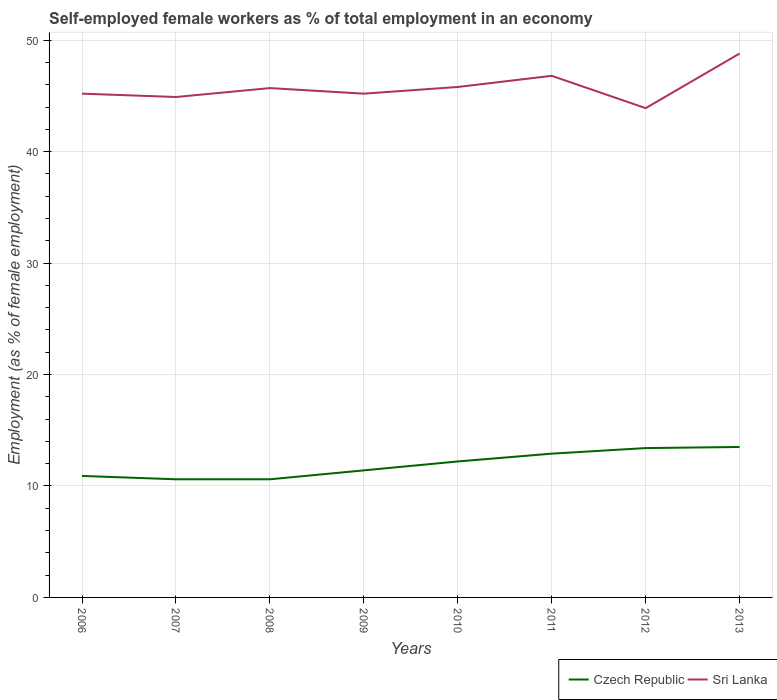How many different coloured lines are there?
Provide a short and direct response. 2. Is the number of lines equal to the number of legend labels?
Provide a short and direct response. Yes. Across all years, what is the maximum percentage of self-employed female workers in Czech Republic?
Provide a short and direct response. 10.6. In which year was the percentage of self-employed female workers in Sri Lanka maximum?
Offer a terse response. 2012. What is the total percentage of self-employed female workers in Sri Lanka in the graph?
Give a very brief answer. -0.6. What is the difference between the highest and the second highest percentage of self-employed female workers in Sri Lanka?
Offer a terse response. 4.9. How many lines are there?
Provide a short and direct response. 2. Are the values on the major ticks of Y-axis written in scientific E-notation?
Ensure brevity in your answer.  No. Does the graph contain grids?
Provide a succinct answer. Yes. Where does the legend appear in the graph?
Give a very brief answer. Bottom right. How many legend labels are there?
Offer a very short reply. 2. What is the title of the graph?
Your answer should be compact. Self-employed female workers as % of total employment in an economy. What is the label or title of the Y-axis?
Give a very brief answer. Employment (as % of female employment). What is the Employment (as % of female employment) of Czech Republic in 2006?
Give a very brief answer. 10.9. What is the Employment (as % of female employment) of Sri Lanka in 2006?
Ensure brevity in your answer.  45.2. What is the Employment (as % of female employment) in Czech Republic in 2007?
Make the answer very short. 10.6. What is the Employment (as % of female employment) in Sri Lanka in 2007?
Offer a very short reply. 44.9. What is the Employment (as % of female employment) in Czech Republic in 2008?
Keep it short and to the point. 10.6. What is the Employment (as % of female employment) of Sri Lanka in 2008?
Provide a short and direct response. 45.7. What is the Employment (as % of female employment) in Czech Republic in 2009?
Give a very brief answer. 11.4. What is the Employment (as % of female employment) in Sri Lanka in 2009?
Your response must be concise. 45.2. What is the Employment (as % of female employment) in Czech Republic in 2010?
Make the answer very short. 12.2. What is the Employment (as % of female employment) of Sri Lanka in 2010?
Provide a short and direct response. 45.8. What is the Employment (as % of female employment) of Czech Republic in 2011?
Offer a terse response. 12.9. What is the Employment (as % of female employment) in Sri Lanka in 2011?
Keep it short and to the point. 46.8. What is the Employment (as % of female employment) of Czech Republic in 2012?
Your response must be concise. 13.4. What is the Employment (as % of female employment) of Sri Lanka in 2012?
Provide a succinct answer. 43.9. What is the Employment (as % of female employment) of Sri Lanka in 2013?
Provide a short and direct response. 48.8. Across all years, what is the maximum Employment (as % of female employment) of Czech Republic?
Provide a succinct answer. 13.5. Across all years, what is the maximum Employment (as % of female employment) of Sri Lanka?
Provide a short and direct response. 48.8. Across all years, what is the minimum Employment (as % of female employment) of Czech Republic?
Give a very brief answer. 10.6. Across all years, what is the minimum Employment (as % of female employment) of Sri Lanka?
Provide a short and direct response. 43.9. What is the total Employment (as % of female employment) of Czech Republic in the graph?
Keep it short and to the point. 95.5. What is the total Employment (as % of female employment) in Sri Lanka in the graph?
Keep it short and to the point. 366.3. What is the difference between the Employment (as % of female employment) of Czech Republic in 2006 and that in 2007?
Provide a succinct answer. 0.3. What is the difference between the Employment (as % of female employment) in Czech Republic in 2006 and that in 2008?
Offer a terse response. 0.3. What is the difference between the Employment (as % of female employment) in Sri Lanka in 2006 and that in 2008?
Your answer should be compact. -0.5. What is the difference between the Employment (as % of female employment) of Czech Republic in 2006 and that in 2009?
Your answer should be very brief. -0.5. What is the difference between the Employment (as % of female employment) of Czech Republic in 2006 and that in 2011?
Keep it short and to the point. -2. What is the difference between the Employment (as % of female employment) of Czech Republic in 2006 and that in 2012?
Give a very brief answer. -2.5. What is the difference between the Employment (as % of female employment) in Sri Lanka in 2006 and that in 2012?
Your answer should be compact. 1.3. What is the difference between the Employment (as % of female employment) in Czech Republic in 2007 and that in 2008?
Provide a succinct answer. 0. What is the difference between the Employment (as % of female employment) in Sri Lanka in 2007 and that in 2008?
Give a very brief answer. -0.8. What is the difference between the Employment (as % of female employment) of Czech Republic in 2007 and that in 2009?
Offer a terse response. -0.8. What is the difference between the Employment (as % of female employment) in Czech Republic in 2007 and that in 2010?
Make the answer very short. -1.6. What is the difference between the Employment (as % of female employment) of Czech Republic in 2007 and that in 2011?
Provide a short and direct response. -2.3. What is the difference between the Employment (as % of female employment) of Sri Lanka in 2007 and that in 2012?
Ensure brevity in your answer.  1. What is the difference between the Employment (as % of female employment) in Czech Republic in 2008 and that in 2011?
Your answer should be compact. -2.3. What is the difference between the Employment (as % of female employment) in Sri Lanka in 2008 and that in 2011?
Make the answer very short. -1.1. What is the difference between the Employment (as % of female employment) of Czech Republic in 2008 and that in 2012?
Keep it short and to the point. -2.8. What is the difference between the Employment (as % of female employment) in Czech Republic in 2008 and that in 2013?
Offer a terse response. -2.9. What is the difference between the Employment (as % of female employment) in Sri Lanka in 2008 and that in 2013?
Give a very brief answer. -3.1. What is the difference between the Employment (as % of female employment) of Czech Republic in 2009 and that in 2010?
Keep it short and to the point. -0.8. What is the difference between the Employment (as % of female employment) of Sri Lanka in 2009 and that in 2010?
Your response must be concise. -0.6. What is the difference between the Employment (as % of female employment) in Sri Lanka in 2009 and that in 2011?
Ensure brevity in your answer.  -1.6. What is the difference between the Employment (as % of female employment) of Czech Republic in 2009 and that in 2012?
Provide a succinct answer. -2. What is the difference between the Employment (as % of female employment) of Sri Lanka in 2009 and that in 2013?
Make the answer very short. -3.6. What is the difference between the Employment (as % of female employment) of Czech Republic in 2010 and that in 2011?
Ensure brevity in your answer.  -0.7. What is the difference between the Employment (as % of female employment) in Czech Republic in 2010 and that in 2013?
Ensure brevity in your answer.  -1.3. What is the difference between the Employment (as % of female employment) in Czech Republic in 2011 and that in 2012?
Provide a short and direct response. -0.5. What is the difference between the Employment (as % of female employment) of Sri Lanka in 2011 and that in 2012?
Your answer should be very brief. 2.9. What is the difference between the Employment (as % of female employment) in Sri Lanka in 2011 and that in 2013?
Ensure brevity in your answer.  -2. What is the difference between the Employment (as % of female employment) in Czech Republic in 2012 and that in 2013?
Ensure brevity in your answer.  -0.1. What is the difference between the Employment (as % of female employment) in Czech Republic in 2006 and the Employment (as % of female employment) in Sri Lanka in 2007?
Give a very brief answer. -34. What is the difference between the Employment (as % of female employment) in Czech Republic in 2006 and the Employment (as % of female employment) in Sri Lanka in 2008?
Offer a very short reply. -34.8. What is the difference between the Employment (as % of female employment) of Czech Republic in 2006 and the Employment (as % of female employment) of Sri Lanka in 2009?
Ensure brevity in your answer.  -34.3. What is the difference between the Employment (as % of female employment) in Czech Republic in 2006 and the Employment (as % of female employment) in Sri Lanka in 2010?
Give a very brief answer. -34.9. What is the difference between the Employment (as % of female employment) in Czech Republic in 2006 and the Employment (as % of female employment) in Sri Lanka in 2011?
Provide a short and direct response. -35.9. What is the difference between the Employment (as % of female employment) in Czech Republic in 2006 and the Employment (as % of female employment) in Sri Lanka in 2012?
Ensure brevity in your answer.  -33. What is the difference between the Employment (as % of female employment) in Czech Republic in 2006 and the Employment (as % of female employment) in Sri Lanka in 2013?
Provide a succinct answer. -37.9. What is the difference between the Employment (as % of female employment) in Czech Republic in 2007 and the Employment (as % of female employment) in Sri Lanka in 2008?
Offer a very short reply. -35.1. What is the difference between the Employment (as % of female employment) in Czech Republic in 2007 and the Employment (as % of female employment) in Sri Lanka in 2009?
Offer a terse response. -34.6. What is the difference between the Employment (as % of female employment) of Czech Republic in 2007 and the Employment (as % of female employment) of Sri Lanka in 2010?
Make the answer very short. -35.2. What is the difference between the Employment (as % of female employment) of Czech Republic in 2007 and the Employment (as % of female employment) of Sri Lanka in 2011?
Your answer should be compact. -36.2. What is the difference between the Employment (as % of female employment) of Czech Republic in 2007 and the Employment (as % of female employment) of Sri Lanka in 2012?
Give a very brief answer. -33.3. What is the difference between the Employment (as % of female employment) of Czech Republic in 2007 and the Employment (as % of female employment) of Sri Lanka in 2013?
Your answer should be very brief. -38.2. What is the difference between the Employment (as % of female employment) in Czech Republic in 2008 and the Employment (as % of female employment) in Sri Lanka in 2009?
Provide a short and direct response. -34.6. What is the difference between the Employment (as % of female employment) of Czech Republic in 2008 and the Employment (as % of female employment) of Sri Lanka in 2010?
Offer a terse response. -35.2. What is the difference between the Employment (as % of female employment) of Czech Republic in 2008 and the Employment (as % of female employment) of Sri Lanka in 2011?
Ensure brevity in your answer.  -36.2. What is the difference between the Employment (as % of female employment) in Czech Republic in 2008 and the Employment (as % of female employment) in Sri Lanka in 2012?
Offer a very short reply. -33.3. What is the difference between the Employment (as % of female employment) in Czech Republic in 2008 and the Employment (as % of female employment) in Sri Lanka in 2013?
Your answer should be compact. -38.2. What is the difference between the Employment (as % of female employment) in Czech Republic in 2009 and the Employment (as % of female employment) in Sri Lanka in 2010?
Offer a very short reply. -34.4. What is the difference between the Employment (as % of female employment) of Czech Republic in 2009 and the Employment (as % of female employment) of Sri Lanka in 2011?
Offer a very short reply. -35.4. What is the difference between the Employment (as % of female employment) of Czech Republic in 2009 and the Employment (as % of female employment) of Sri Lanka in 2012?
Provide a succinct answer. -32.5. What is the difference between the Employment (as % of female employment) of Czech Republic in 2009 and the Employment (as % of female employment) of Sri Lanka in 2013?
Provide a succinct answer. -37.4. What is the difference between the Employment (as % of female employment) in Czech Republic in 2010 and the Employment (as % of female employment) in Sri Lanka in 2011?
Provide a succinct answer. -34.6. What is the difference between the Employment (as % of female employment) of Czech Republic in 2010 and the Employment (as % of female employment) of Sri Lanka in 2012?
Your answer should be very brief. -31.7. What is the difference between the Employment (as % of female employment) in Czech Republic in 2010 and the Employment (as % of female employment) in Sri Lanka in 2013?
Keep it short and to the point. -36.6. What is the difference between the Employment (as % of female employment) of Czech Republic in 2011 and the Employment (as % of female employment) of Sri Lanka in 2012?
Ensure brevity in your answer.  -31. What is the difference between the Employment (as % of female employment) in Czech Republic in 2011 and the Employment (as % of female employment) in Sri Lanka in 2013?
Give a very brief answer. -35.9. What is the difference between the Employment (as % of female employment) in Czech Republic in 2012 and the Employment (as % of female employment) in Sri Lanka in 2013?
Provide a succinct answer. -35.4. What is the average Employment (as % of female employment) in Czech Republic per year?
Your answer should be compact. 11.94. What is the average Employment (as % of female employment) in Sri Lanka per year?
Your response must be concise. 45.79. In the year 2006, what is the difference between the Employment (as % of female employment) of Czech Republic and Employment (as % of female employment) of Sri Lanka?
Your answer should be compact. -34.3. In the year 2007, what is the difference between the Employment (as % of female employment) in Czech Republic and Employment (as % of female employment) in Sri Lanka?
Your answer should be very brief. -34.3. In the year 2008, what is the difference between the Employment (as % of female employment) in Czech Republic and Employment (as % of female employment) in Sri Lanka?
Offer a very short reply. -35.1. In the year 2009, what is the difference between the Employment (as % of female employment) in Czech Republic and Employment (as % of female employment) in Sri Lanka?
Your answer should be very brief. -33.8. In the year 2010, what is the difference between the Employment (as % of female employment) of Czech Republic and Employment (as % of female employment) of Sri Lanka?
Your response must be concise. -33.6. In the year 2011, what is the difference between the Employment (as % of female employment) in Czech Republic and Employment (as % of female employment) in Sri Lanka?
Ensure brevity in your answer.  -33.9. In the year 2012, what is the difference between the Employment (as % of female employment) in Czech Republic and Employment (as % of female employment) in Sri Lanka?
Offer a very short reply. -30.5. In the year 2013, what is the difference between the Employment (as % of female employment) in Czech Republic and Employment (as % of female employment) in Sri Lanka?
Offer a terse response. -35.3. What is the ratio of the Employment (as % of female employment) of Czech Republic in 2006 to that in 2007?
Your response must be concise. 1.03. What is the ratio of the Employment (as % of female employment) of Sri Lanka in 2006 to that in 2007?
Provide a short and direct response. 1.01. What is the ratio of the Employment (as % of female employment) in Czech Republic in 2006 to that in 2008?
Ensure brevity in your answer.  1.03. What is the ratio of the Employment (as % of female employment) in Sri Lanka in 2006 to that in 2008?
Make the answer very short. 0.99. What is the ratio of the Employment (as % of female employment) of Czech Republic in 2006 to that in 2009?
Offer a very short reply. 0.96. What is the ratio of the Employment (as % of female employment) in Czech Republic in 2006 to that in 2010?
Provide a succinct answer. 0.89. What is the ratio of the Employment (as % of female employment) of Sri Lanka in 2006 to that in 2010?
Ensure brevity in your answer.  0.99. What is the ratio of the Employment (as % of female employment) of Czech Republic in 2006 to that in 2011?
Provide a succinct answer. 0.84. What is the ratio of the Employment (as % of female employment) of Sri Lanka in 2006 to that in 2011?
Your answer should be compact. 0.97. What is the ratio of the Employment (as % of female employment) of Czech Republic in 2006 to that in 2012?
Provide a succinct answer. 0.81. What is the ratio of the Employment (as % of female employment) in Sri Lanka in 2006 to that in 2012?
Your answer should be very brief. 1.03. What is the ratio of the Employment (as % of female employment) in Czech Republic in 2006 to that in 2013?
Offer a terse response. 0.81. What is the ratio of the Employment (as % of female employment) of Sri Lanka in 2006 to that in 2013?
Keep it short and to the point. 0.93. What is the ratio of the Employment (as % of female employment) of Czech Republic in 2007 to that in 2008?
Your answer should be compact. 1. What is the ratio of the Employment (as % of female employment) in Sri Lanka in 2007 to that in 2008?
Your answer should be very brief. 0.98. What is the ratio of the Employment (as % of female employment) in Czech Republic in 2007 to that in 2009?
Give a very brief answer. 0.93. What is the ratio of the Employment (as % of female employment) of Sri Lanka in 2007 to that in 2009?
Provide a short and direct response. 0.99. What is the ratio of the Employment (as % of female employment) of Czech Republic in 2007 to that in 2010?
Offer a very short reply. 0.87. What is the ratio of the Employment (as % of female employment) in Sri Lanka in 2007 to that in 2010?
Provide a succinct answer. 0.98. What is the ratio of the Employment (as % of female employment) in Czech Republic in 2007 to that in 2011?
Provide a succinct answer. 0.82. What is the ratio of the Employment (as % of female employment) in Sri Lanka in 2007 to that in 2011?
Your answer should be compact. 0.96. What is the ratio of the Employment (as % of female employment) in Czech Republic in 2007 to that in 2012?
Give a very brief answer. 0.79. What is the ratio of the Employment (as % of female employment) in Sri Lanka in 2007 to that in 2012?
Your response must be concise. 1.02. What is the ratio of the Employment (as % of female employment) of Czech Republic in 2007 to that in 2013?
Keep it short and to the point. 0.79. What is the ratio of the Employment (as % of female employment) of Sri Lanka in 2007 to that in 2013?
Your answer should be very brief. 0.92. What is the ratio of the Employment (as % of female employment) of Czech Republic in 2008 to that in 2009?
Your answer should be very brief. 0.93. What is the ratio of the Employment (as % of female employment) in Sri Lanka in 2008 to that in 2009?
Keep it short and to the point. 1.01. What is the ratio of the Employment (as % of female employment) in Czech Republic in 2008 to that in 2010?
Give a very brief answer. 0.87. What is the ratio of the Employment (as % of female employment) in Sri Lanka in 2008 to that in 2010?
Provide a succinct answer. 1. What is the ratio of the Employment (as % of female employment) in Czech Republic in 2008 to that in 2011?
Provide a succinct answer. 0.82. What is the ratio of the Employment (as % of female employment) in Sri Lanka in 2008 to that in 2011?
Your answer should be very brief. 0.98. What is the ratio of the Employment (as % of female employment) of Czech Republic in 2008 to that in 2012?
Provide a succinct answer. 0.79. What is the ratio of the Employment (as % of female employment) of Sri Lanka in 2008 to that in 2012?
Offer a very short reply. 1.04. What is the ratio of the Employment (as % of female employment) of Czech Republic in 2008 to that in 2013?
Ensure brevity in your answer.  0.79. What is the ratio of the Employment (as % of female employment) of Sri Lanka in 2008 to that in 2013?
Provide a succinct answer. 0.94. What is the ratio of the Employment (as % of female employment) of Czech Republic in 2009 to that in 2010?
Offer a very short reply. 0.93. What is the ratio of the Employment (as % of female employment) in Sri Lanka in 2009 to that in 2010?
Your answer should be very brief. 0.99. What is the ratio of the Employment (as % of female employment) of Czech Republic in 2009 to that in 2011?
Your answer should be very brief. 0.88. What is the ratio of the Employment (as % of female employment) of Sri Lanka in 2009 to that in 2011?
Offer a terse response. 0.97. What is the ratio of the Employment (as % of female employment) in Czech Republic in 2009 to that in 2012?
Your response must be concise. 0.85. What is the ratio of the Employment (as % of female employment) in Sri Lanka in 2009 to that in 2012?
Offer a terse response. 1.03. What is the ratio of the Employment (as % of female employment) in Czech Republic in 2009 to that in 2013?
Offer a very short reply. 0.84. What is the ratio of the Employment (as % of female employment) in Sri Lanka in 2009 to that in 2013?
Offer a very short reply. 0.93. What is the ratio of the Employment (as % of female employment) of Czech Republic in 2010 to that in 2011?
Offer a very short reply. 0.95. What is the ratio of the Employment (as % of female employment) in Sri Lanka in 2010 to that in 2011?
Offer a terse response. 0.98. What is the ratio of the Employment (as % of female employment) of Czech Republic in 2010 to that in 2012?
Make the answer very short. 0.91. What is the ratio of the Employment (as % of female employment) in Sri Lanka in 2010 to that in 2012?
Keep it short and to the point. 1.04. What is the ratio of the Employment (as % of female employment) in Czech Republic in 2010 to that in 2013?
Your answer should be compact. 0.9. What is the ratio of the Employment (as % of female employment) in Sri Lanka in 2010 to that in 2013?
Offer a terse response. 0.94. What is the ratio of the Employment (as % of female employment) in Czech Republic in 2011 to that in 2012?
Ensure brevity in your answer.  0.96. What is the ratio of the Employment (as % of female employment) of Sri Lanka in 2011 to that in 2012?
Your answer should be compact. 1.07. What is the ratio of the Employment (as % of female employment) of Czech Republic in 2011 to that in 2013?
Provide a short and direct response. 0.96. What is the ratio of the Employment (as % of female employment) in Sri Lanka in 2011 to that in 2013?
Provide a succinct answer. 0.96. What is the ratio of the Employment (as % of female employment) of Sri Lanka in 2012 to that in 2013?
Provide a short and direct response. 0.9. What is the difference between the highest and the second highest Employment (as % of female employment) of Czech Republic?
Your answer should be compact. 0.1. What is the difference between the highest and the second highest Employment (as % of female employment) of Sri Lanka?
Provide a succinct answer. 2. What is the difference between the highest and the lowest Employment (as % of female employment) of Czech Republic?
Provide a short and direct response. 2.9. 